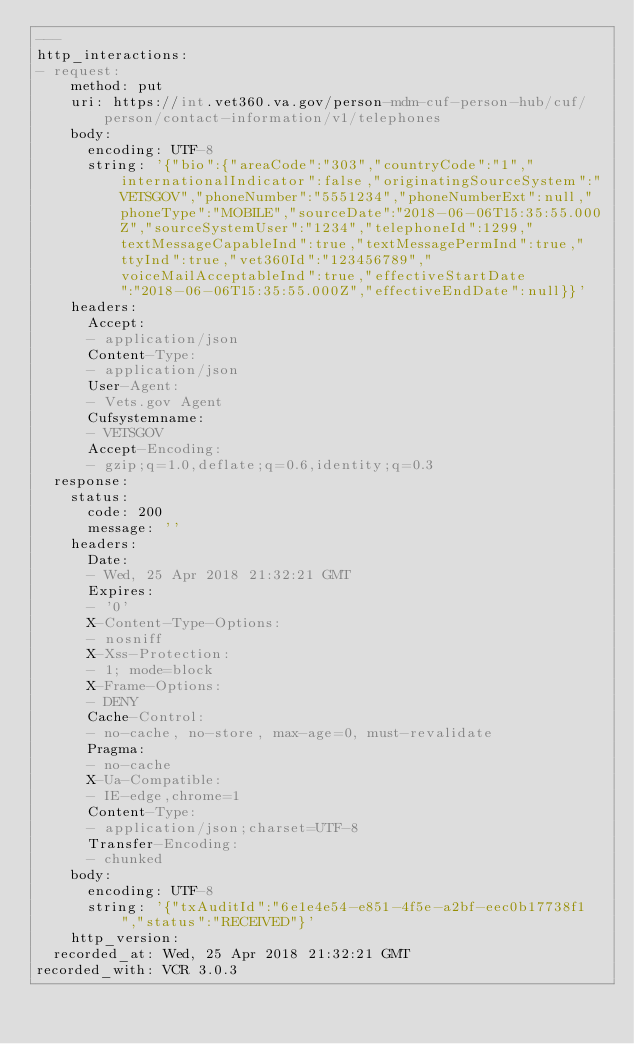Convert code to text. <code><loc_0><loc_0><loc_500><loc_500><_YAML_>---
http_interactions:
- request:
    method: put
    uri: https://int.vet360.va.gov/person-mdm-cuf-person-hub/cuf/person/contact-information/v1/telephones
    body:
      encoding: UTF-8
      string: '{"bio":{"areaCode":"303","countryCode":"1","internationalIndicator":false,"originatingSourceSystem":"VETSGOV","phoneNumber":"5551234","phoneNumberExt":null,"phoneType":"MOBILE","sourceDate":"2018-06-06T15:35:55.000Z","sourceSystemUser":"1234","telephoneId":1299,"textMessageCapableInd":true,"textMessagePermInd":true,"ttyInd":true,"vet360Id":"123456789","voiceMailAcceptableInd":true,"effectiveStartDate":"2018-06-06T15:35:55.000Z","effectiveEndDate":null}}'
    headers:
      Accept:
      - application/json
      Content-Type:
      - application/json
      User-Agent:
      - Vets.gov Agent
      Cufsystemname:
      - VETSGOV
      Accept-Encoding:
      - gzip;q=1.0,deflate;q=0.6,identity;q=0.3
  response:
    status:
      code: 200
      message: ''
    headers:
      Date:
      - Wed, 25 Apr 2018 21:32:21 GMT
      Expires:
      - '0'
      X-Content-Type-Options:
      - nosniff
      X-Xss-Protection:
      - 1; mode=block
      X-Frame-Options:
      - DENY
      Cache-Control:
      - no-cache, no-store, max-age=0, must-revalidate
      Pragma:
      - no-cache
      X-Ua-Compatible:
      - IE-edge,chrome=1
      Content-Type:
      - application/json;charset=UTF-8
      Transfer-Encoding:
      - chunked
    body:
      encoding: UTF-8
      string: '{"txAuditId":"6e1e4e54-e851-4f5e-a2bf-eec0b17738f1","status":"RECEIVED"}'
    http_version:
  recorded_at: Wed, 25 Apr 2018 21:32:21 GMT
recorded_with: VCR 3.0.3
</code> 